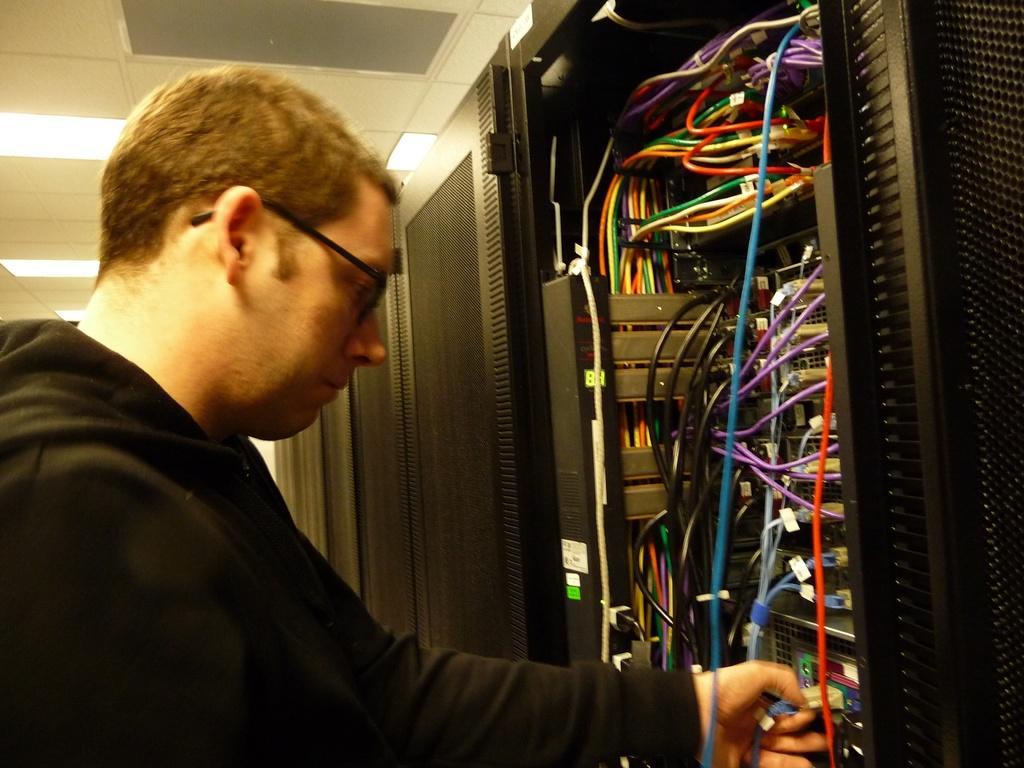Could you give a brief overview of what you see in this image? In this image I can see a person wearing a black t shirt and spectacles. There are wires and black doors on the right. There are lights at the top. 